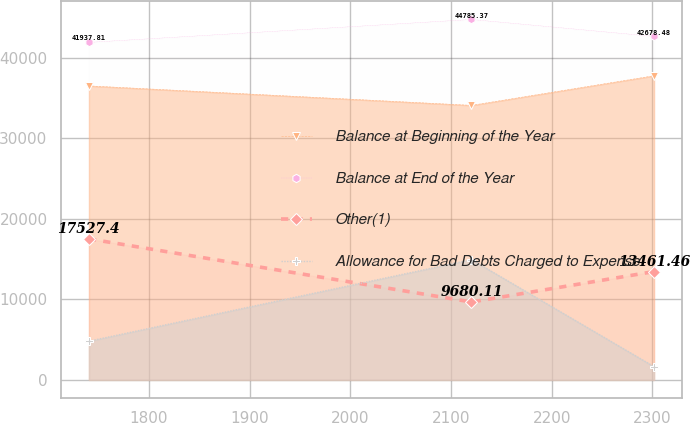Convert chart to OTSL. <chart><loc_0><loc_0><loc_500><loc_500><line_chart><ecel><fcel>Balance at Beginning of the Year<fcel>Balance at End of the Year<fcel>Other(1)<fcel>Allowance for Bad Debts Charged to Expense<nl><fcel>1740.4<fcel>36531.2<fcel>41937.8<fcel>17527.4<fcel>4812.5<nl><fcel>2120.35<fcel>34111.4<fcel>44785.4<fcel>9680.11<fcel>14944.9<nl><fcel>2301.69<fcel>37791.3<fcel>42678.5<fcel>13461.5<fcel>1645.85<nl></chart> 